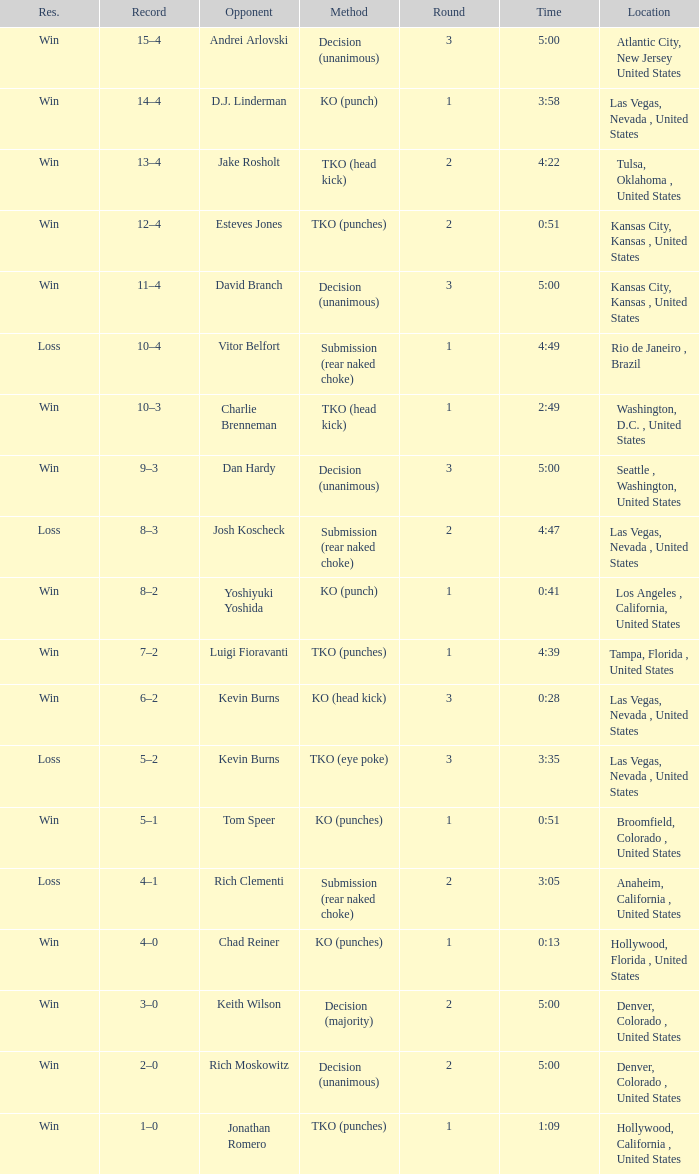What record has a time of 13 seconds? 4–0. 